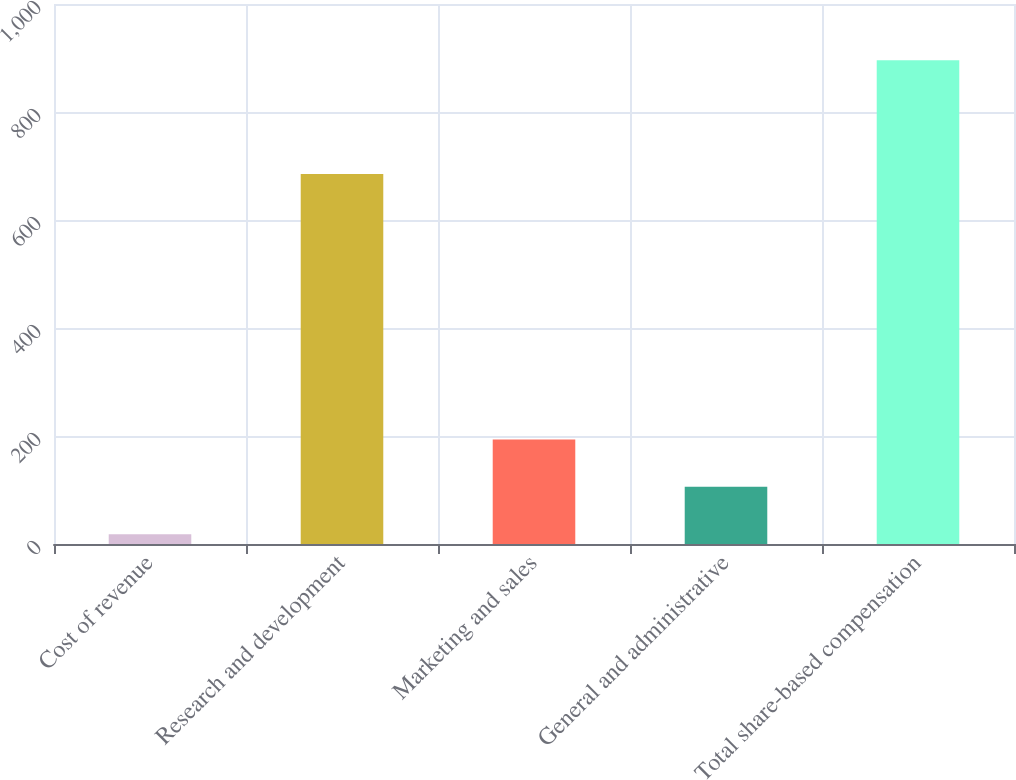<chart> <loc_0><loc_0><loc_500><loc_500><bar_chart><fcel>Cost of revenue<fcel>Research and development<fcel>Marketing and sales<fcel>General and administrative<fcel>Total share-based compensation<nl><fcel>18<fcel>685<fcel>193.6<fcel>105.8<fcel>896<nl></chart> 